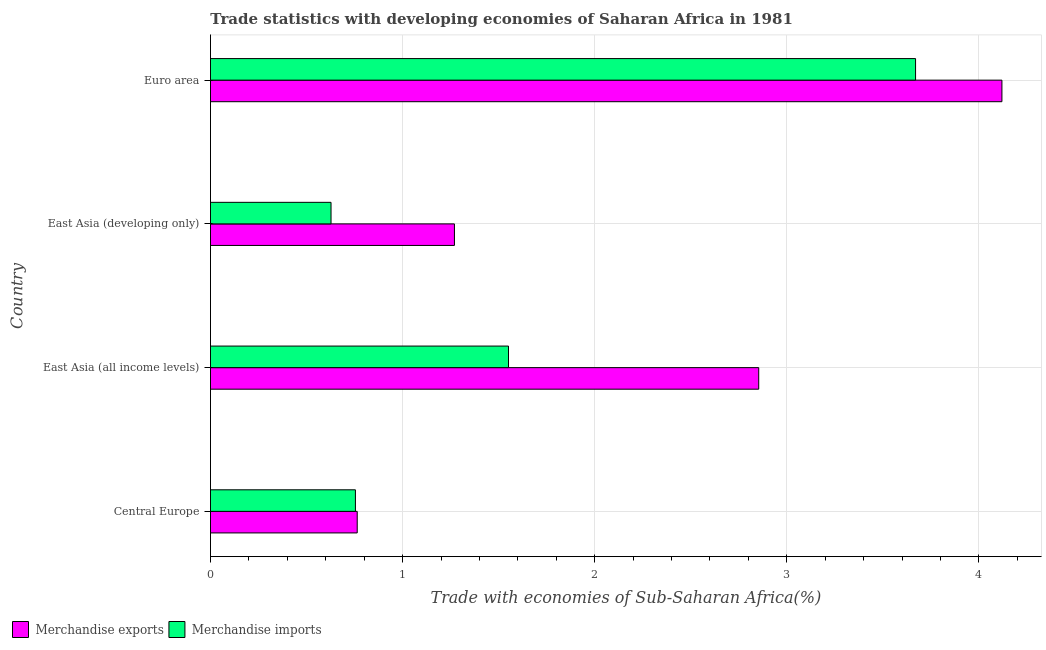How many groups of bars are there?
Provide a succinct answer. 4. Are the number of bars per tick equal to the number of legend labels?
Your answer should be very brief. Yes. What is the label of the 2nd group of bars from the top?
Keep it short and to the point. East Asia (developing only). What is the merchandise exports in East Asia (all income levels)?
Offer a terse response. 2.85. Across all countries, what is the maximum merchandise imports?
Provide a succinct answer. 3.67. Across all countries, what is the minimum merchandise imports?
Make the answer very short. 0.63. In which country was the merchandise imports maximum?
Offer a very short reply. Euro area. In which country was the merchandise imports minimum?
Give a very brief answer. East Asia (developing only). What is the total merchandise exports in the graph?
Your response must be concise. 9.01. What is the difference between the merchandise exports in Central Europe and that in East Asia (developing only)?
Provide a short and direct response. -0.51. What is the difference between the merchandise imports in Euro area and the merchandise exports in East Asia (all income levels)?
Your response must be concise. 0.82. What is the average merchandise imports per country?
Ensure brevity in your answer.  1.65. What is the difference between the merchandise imports and merchandise exports in Central Europe?
Provide a succinct answer. -0.01. In how many countries, is the merchandise exports greater than 3.2 %?
Make the answer very short. 1. What is the ratio of the merchandise exports in East Asia (developing only) to that in Euro area?
Offer a very short reply. 0.31. Is the merchandise exports in East Asia (all income levels) less than that in East Asia (developing only)?
Provide a short and direct response. No. What is the difference between the highest and the second highest merchandise imports?
Your answer should be very brief. 2.12. What is the difference between the highest and the lowest merchandise exports?
Your answer should be compact. 3.36. In how many countries, is the merchandise exports greater than the average merchandise exports taken over all countries?
Ensure brevity in your answer.  2. Is the sum of the merchandise imports in East Asia (developing only) and Euro area greater than the maximum merchandise exports across all countries?
Ensure brevity in your answer.  Yes. What does the 1st bar from the top in Central Europe represents?
Offer a terse response. Merchandise imports. How many bars are there?
Your answer should be very brief. 8. Are all the bars in the graph horizontal?
Offer a terse response. Yes. Are the values on the major ticks of X-axis written in scientific E-notation?
Offer a very short reply. No. Does the graph contain grids?
Keep it short and to the point. Yes. Where does the legend appear in the graph?
Your response must be concise. Bottom left. What is the title of the graph?
Your response must be concise. Trade statistics with developing economies of Saharan Africa in 1981. Does "Urban" appear as one of the legend labels in the graph?
Provide a succinct answer. No. What is the label or title of the X-axis?
Keep it short and to the point. Trade with economies of Sub-Saharan Africa(%). What is the label or title of the Y-axis?
Ensure brevity in your answer.  Country. What is the Trade with economies of Sub-Saharan Africa(%) in Merchandise exports in Central Europe?
Provide a succinct answer. 0.76. What is the Trade with economies of Sub-Saharan Africa(%) in Merchandise imports in Central Europe?
Provide a short and direct response. 0.75. What is the Trade with economies of Sub-Saharan Africa(%) in Merchandise exports in East Asia (all income levels)?
Your response must be concise. 2.85. What is the Trade with economies of Sub-Saharan Africa(%) of Merchandise imports in East Asia (all income levels)?
Your response must be concise. 1.55. What is the Trade with economies of Sub-Saharan Africa(%) of Merchandise exports in East Asia (developing only)?
Your response must be concise. 1.27. What is the Trade with economies of Sub-Saharan Africa(%) in Merchandise imports in East Asia (developing only)?
Keep it short and to the point. 0.63. What is the Trade with economies of Sub-Saharan Africa(%) of Merchandise exports in Euro area?
Keep it short and to the point. 4.12. What is the Trade with economies of Sub-Saharan Africa(%) of Merchandise imports in Euro area?
Your response must be concise. 3.67. Across all countries, what is the maximum Trade with economies of Sub-Saharan Africa(%) in Merchandise exports?
Offer a terse response. 4.12. Across all countries, what is the maximum Trade with economies of Sub-Saharan Africa(%) of Merchandise imports?
Keep it short and to the point. 3.67. Across all countries, what is the minimum Trade with economies of Sub-Saharan Africa(%) in Merchandise exports?
Give a very brief answer. 0.76. Across all countries, what is the minimum Trade with economies of Sub-Saharan Africa(%) of Merchandise imports?
Provide a succinct answer. 0.63. What is the total Trade with economies of Sub-Saharan Africa(%) of Merchandise exports in the graph?
Your answer should be compact. 9.01. What is the total Trade with economies of Sub-Saharan Africa(%) of Merchandise imports in the graph?
Offer a very short reply. 6.6. What is the difference between the Trade with economies of Sub-Saharan Africa(%) in Merchandise exports in Central Europe and that in East Asia (all income levels)?
Keep it short and to the point. -2.09. What is the difference between the Trade with economies of Sub-Saharan Africa(%) in Merchandise imports in Central Europe and that in East Asia (all income levels)?
Make the answer very short. -0.8. What is the difference between the Trade with economies of Sub-Saharan Africa(%) in Merchandise exports in Central Europe and that in East Asia (developing only)?
Your response must be concise. -0.51. What is the difference between the Trade with economies of Sub-Saharan Africa(%) of Merchandise imports in Central Europe and that in East Asia (developing only)?
Your answer should be very brief. 0.13. What is the difference between the Trade with economies of Sub-Saharan Africa(%) of Merchandise exports in Central Europe and that in Euro area?
Make the answer very short. -3.36. What is the difference between the Trade with economies of Sub-Saharan Africa(%) of Merchandise imports in Central Europe and that in Euro area?
Keep it short and to the point. -2.92. What is the difference between the Trade with economies of Sub-Saharan Africa(%) of Merchandise exports in East Asia (all income levels) and that in East Asia (developing only)?
Your answer should be very brief. 1.58. What is the difference between the Trade with economies of Sub-Saharan Africa(%) of Merchandise imports in East Asia (all income levels) and that in East Asia (developing only)?
Provide a short and direct response. 0.92. What is the difference between the Trade with economies of Sub-Saharan Africa(%) of Merchandise exports in East Asia (all income levels) and that in Euro area?
Give a very brief answer. -1.27. What is the difference between the Trade with economies of Sub-Saharan Africa(%) of Merchandise imports in East Asia (all income levels) and that in Euro area?
Your response must be concise. -2.12. What is the difference between the Trade with economies of Sub-Saharan Africa(%) in Merchandise exports in East Asia (developing only) and that in Euro area?
Keep it short and to the point. -2.85. What is the difference between the Trade with economies of Sub-Saharan Africa(%) of Merchandise imports in East Asia (developing only) and that in Euro area?
Make the answer very short. -3.04. What is the difference between the Trade with economies of Sub-Saharan Africa(%) of Merchandise exports in Central Europe and the Trade with economies of Sub-Saharan Africa(%) of Merchandise imports in East Asia (all income levels)?
Keep it short and to the point. -0.79. What is the difference between the Trade with economies of Sub-Saharan Africa(%) in Merchandise exports in Central Europe and the Trade with economies of Sub-Saharan Africa(%) in Merchandise imports in East Asia (developing only)?
Offer a terse response. 0.14. What is the difference between the Trade with economies of Sub-Saharan Africa(%) in Merchandise exports in Central Europe and the Trade with economies of Sub-Saharan Africa(%) in Merchandise imports in Euro area?
Provide a succinct answer. -2.91. What is the difference between the Trade with economies of Sub-Saharan Africa(%) of Merchandise exports in East Asia (all income levels) and the Trade with economies of Sub-Saharan Africa(%) of Merchandise imports in East Asia (developing only)?
Ensure brevity in your answer.  2.23. What is the difference between the Trade with economies of Sub-Saharan Africa(%) of Merchandise exports in East Asia (all income levels) and the Trade with economies of Sub-Saharan Africa(%) of Merchandise imports in Euro area?
Your answer should be very brief. -0.82. What is the difference between the Trade with economies of Sub-Saharan Africa(%) in Merchandise exports in East Asia (developing only) and the Trade with economies of Sub-Saharan Africa(%) in Merchandise imports in Euro area?
Give a very brief answer. -2.4. What is the average Trade with economies of Sub-Saharan Africa(%) in Merchandise exports per country?
Ensure brevity in your answer.  2.25. What is the average Trade with economies of Sub-Saharan Africa(%) of Merchandise imports per country?
Your answer should be compact. 1.65. What is the difference between the Trade with economies of Sub-Saharan Africa(%) in Merchandise exports and Trade with economies of Sub-Saharan Africa(%) in Merchandise imports in Central Europe?
Offer a terse response. 0.01. What is the difference between the Trade with economies of Sub-Saharan Africa(%) of Merchandise exports and Trade with economies of Sub-Saharan Africa(%) of Merchandise imports in East Asia (all income levels)?
Ensure brevity in your answer.  1.3. What is the difference between the Trade with economies of Sub-Saharan Africa(%) of Merchandise exports and Trade with economies of Sub-Saharan Africa(%) of Merchandise imports in East Asia (developing only)?
Offer a very short reply. 0.64. What is the difference between the Trade with economies of Sub-Saharan Africa(%) in Merchandise exports and Trade with economies of Sub-Saharan Africa(%) in Merchandise imports in Euro area?
Keep it short and to the point. 0.45. What is the ratio of the Trade with economies of Sub-Saharan Africa(%) in Merchandise exports in Central Europe to that in East Asia (all income levels)?
Your answer should be compact. 0.27. What is the ratio of the Trade with economies of Sub-Saharan Africa(%) in Merchandise imports in Central Europe to that in East Asia (all income levels)?
Provide a succinct answer. 0.49. What is the ratio of the Trade with economies of Sub-Saharan Africa(%) in Merchandise exports in Central Europe to that in East Asia (developing only)?
Provide a short and direct response. 0.6. What is the ratio of the Trade with economies of Sub-Saharan Africa(%) in Merchandise imports in Central Europe to that in East Asia (developing only)?
Your answer should be very brief. 1.2. What is the ratio of the Trade with economies of Sub-Saharan Africa(%) in Merchandise exports in Central Europe to that in Euro area?
Provide a succinct answer. 0.19. What is the ratio of the Trade with economies of Sub-Saharan Africa(%) of Merchandise imports in Central Europe to that in Euro area?
Your answer should be compact. 0.21. What is the ratio of the Trade with economies of Sub-Saharan Africa(%) of Merchandise exports in East Asia (all income levels) to that in East Asia (developing only)?
Your answer should be compact. 2.25. What is the ratio of the Trade with economies of Sub-Saharan Africa(%) in Merchandise imports in East Asia (all income levels) to that in East Asia (developing only)?
Ensure brevity in your answer.  2.47. What is the ratio of the Trade with economies of Sub-Saharan Africa(%) of Merchandise exports in East Asia (all income levels) to that in Euro area?
Ensure brevity in your answer.  0.69. What is the ratio of the Trade with economies of Sub-Saharan Africa(%) of Merchandise imports in East Asia (all income levels) to that in Euro area?
Provide a short and direct response. 0.42. What is the ratio of the Trade with economies of Sub-Saharan Africa(%) in Merchandise exports in East Asia (developing only) to that in Euro area?
Your answer should be compact. 0.31. What is the ratio of the Trade with economies of Sub-Saharan Africa(%) in Merchandise imports in East Asia (developing only) to that in Euro area?
Your answer should be very brief. 0.17. What is the difference between the highest and the second highest Trade with economies of Sub-Saharan Africa(%) of Merchandise exports?
Provide a short and direct response. 1.27. What is the difference between the highest and the second highest Trade with economies of Sub-Saharan Africa(%) in Merchandise imports?
Ensure brevity in your answer.  2.12. What is the difference between the highest and the lowest Trade with economies of Sub-Saharan Africa(%) in Merchandise exports?
Your answer should be very brief. 3.36. What is the difference between the highest and the lowest Trade with economies of Sub-Saharan Africa(%) of Merchandise imports?
Offer a very short reply. 3.04. 